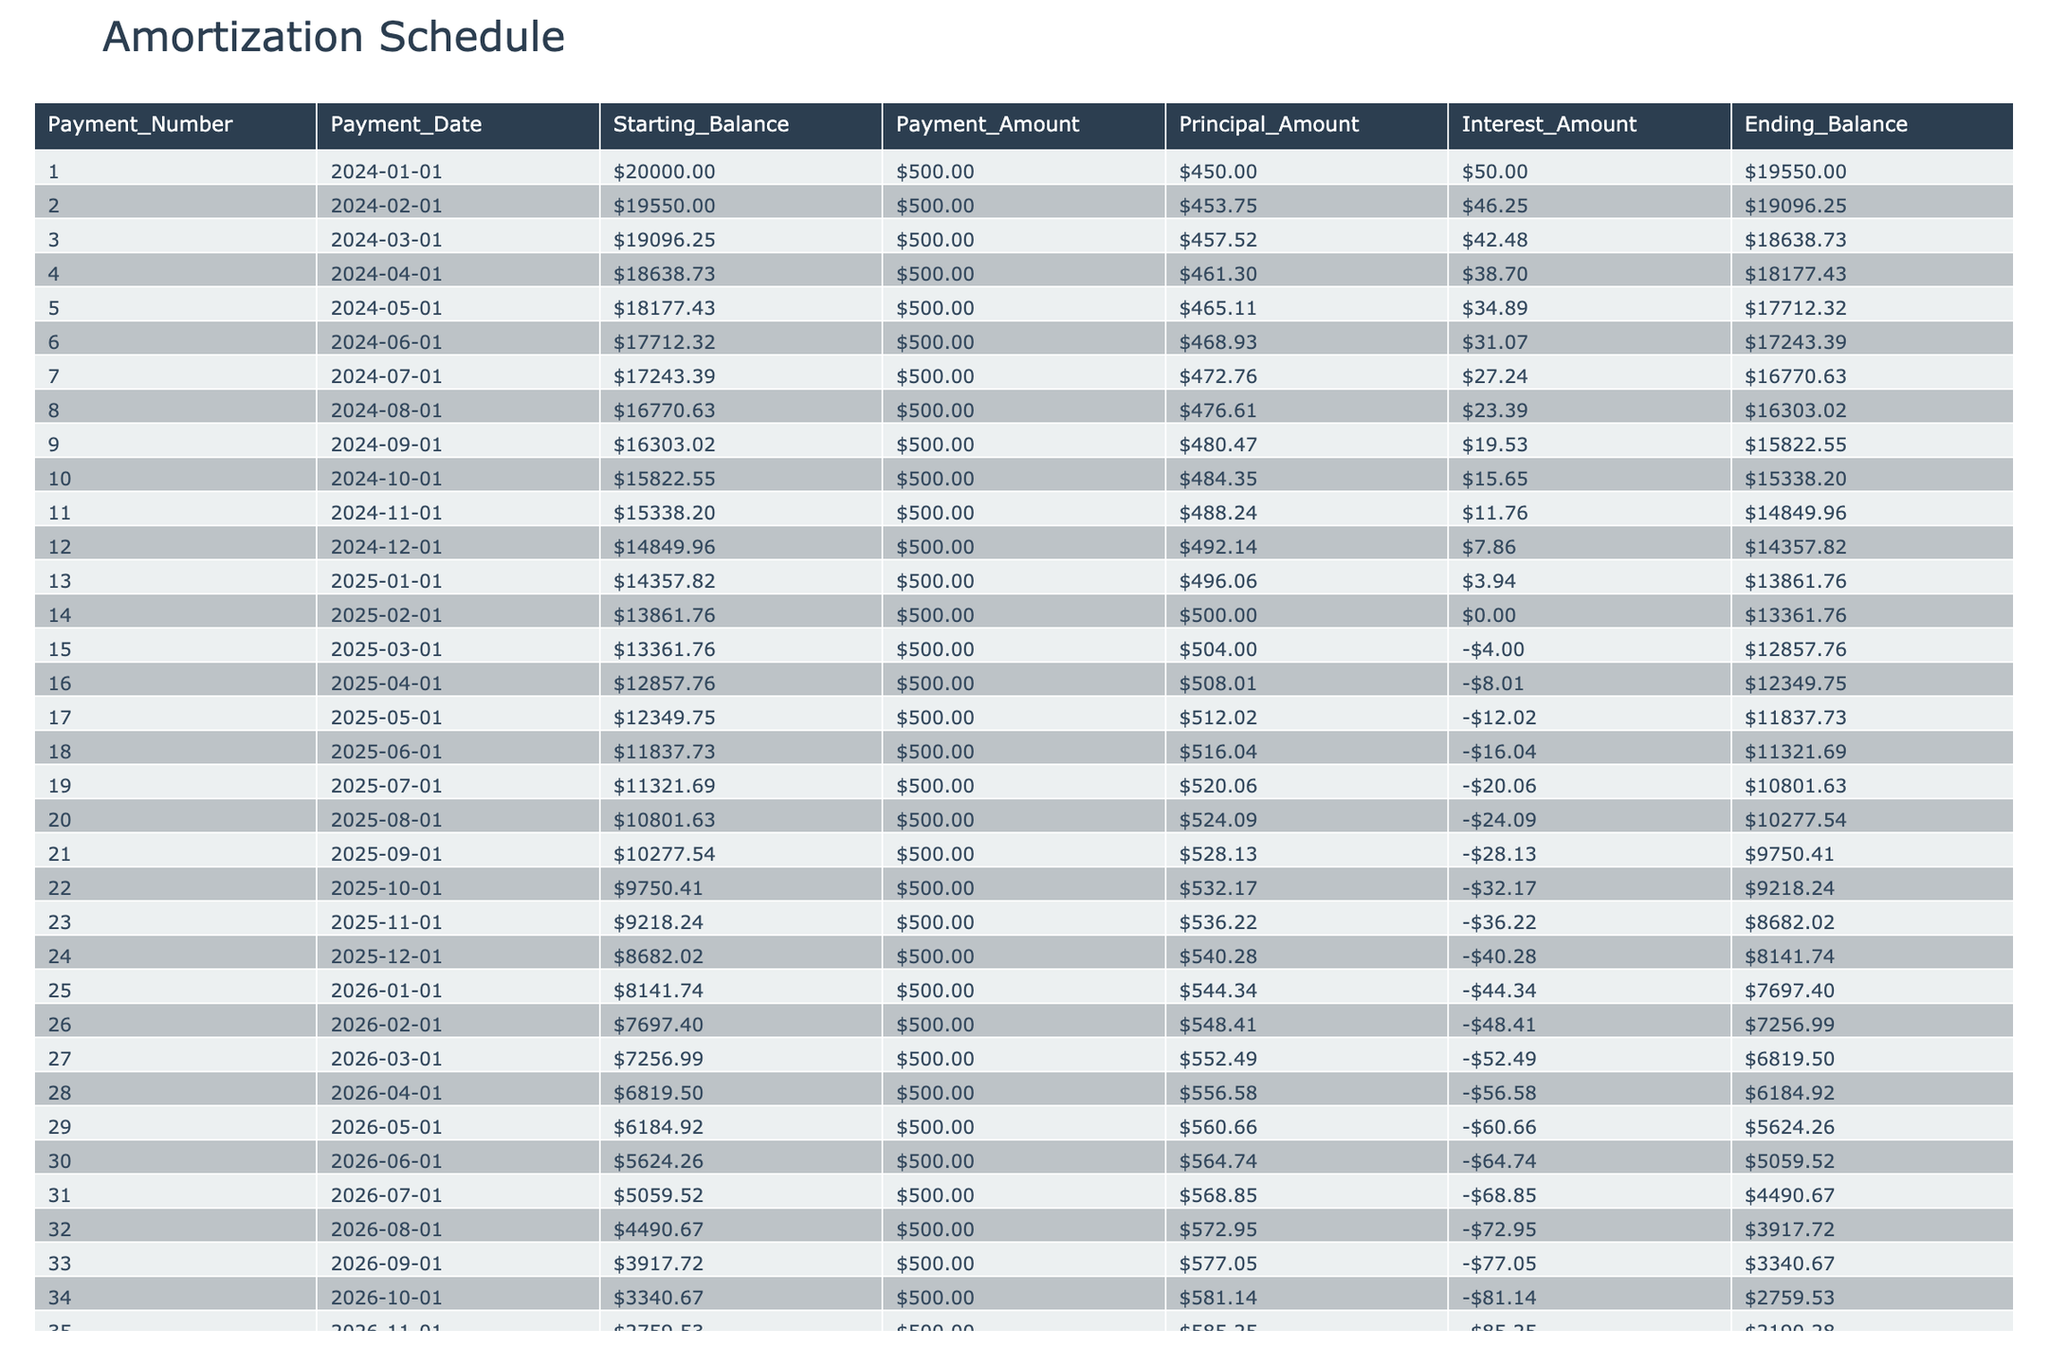What is the payment amount for the first payment? In the table, the Payment Amount for Payment Number 1 is listed directly as 500.00.
Answer: 500.00 What was the starting balance at the end of the first month? The Ending Balance for Payment Number 1, which marks the starting balance for the second payment, is 19550.00.
Answer: 19550.00 How much principal was paid off in the 10th payment? Looking at Payment Number 10, the Principal Amount is stated as 484.35.
Answer: 484.35 What is the total amount of interest paid in the first five payments? To find the total interest for the first five payments, we sum the Interest Amounts: 50.00 + 46.25 + 42.48 + 38.70 + 34.89 = 212.32.
Answer: 212.32 Is the principal portion of the 20th payment more than 500? The Principal Amount for Payment 20 is 524.09; since this is greater than 500, the answer is yes.
Answer: Yes What is the average principal amount paid over the first 12 payments? First, find the sum of the principal amounts for the first 12 payments: (450.00 + 453.75 + 457.52 + 461.30 + 465.11 + 468.93 + 472.76 + 476.61 + 480.47 + 484.35 + 488.24 + 492.14) = 5652.54. Then divide by 12, thus the average is 471.05.
Answer: 471.05 How much the ending balance decreased from the first to the twelfth payment? The Starting Balance for the first payment is 20000.00 and the Ending Balance for the twelfth payment is 14357.82. Therefore, the difference is 20000.00 - 14357.82 = 5642.18.
Answer: 5642.18 Was the total principal paid off by the 14th payment greater than $5000? The total principal paid off until the 14th payment is simply the cumulative sum of the principal amounts, which could be calculated from the table data. After calculating, it equals 6834.12, which is greater than 5000, so the answer is yes.
Answer: Yes How many payments do we have before the ending balance becomes negative? The Ending Balance first becomes negative after Payment Number 39, meaning all the previous payments up to 38 have non-negative balances. Thus, there are 38 payments before it goes negative.
Answer: 38 